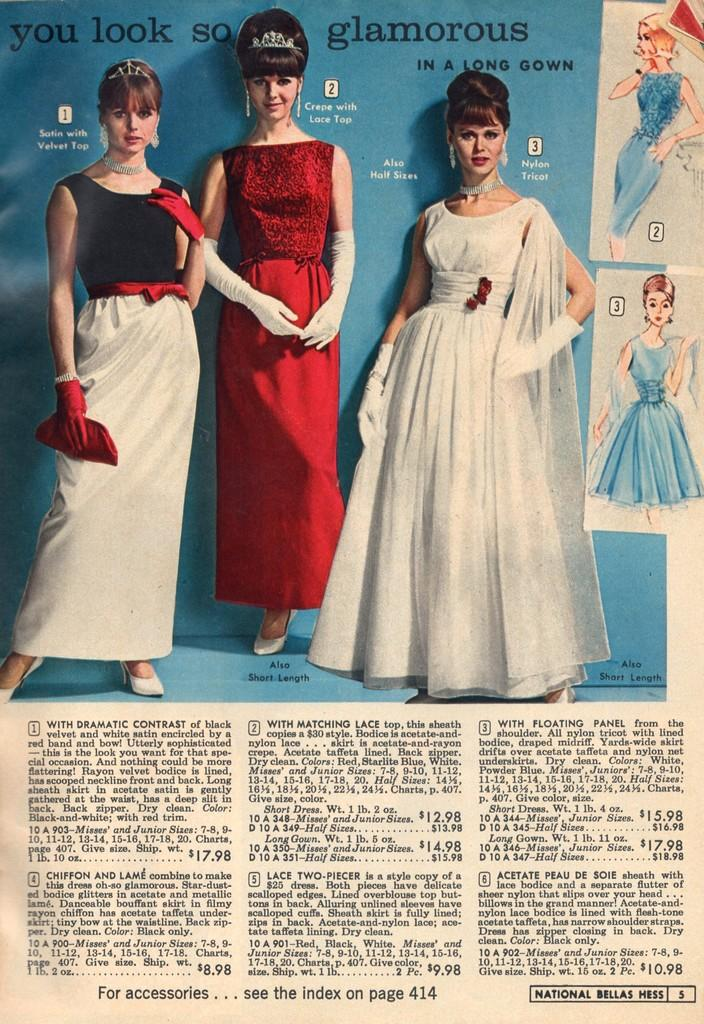What is present in the image? There is a paper in the image. What is written or printed on the paper? The paper contains text. Are there any visual elements on the paper besides the text? Yes, the paper contains images of women. How many children are holding forks in the image? There are no children or forks present in the image. 